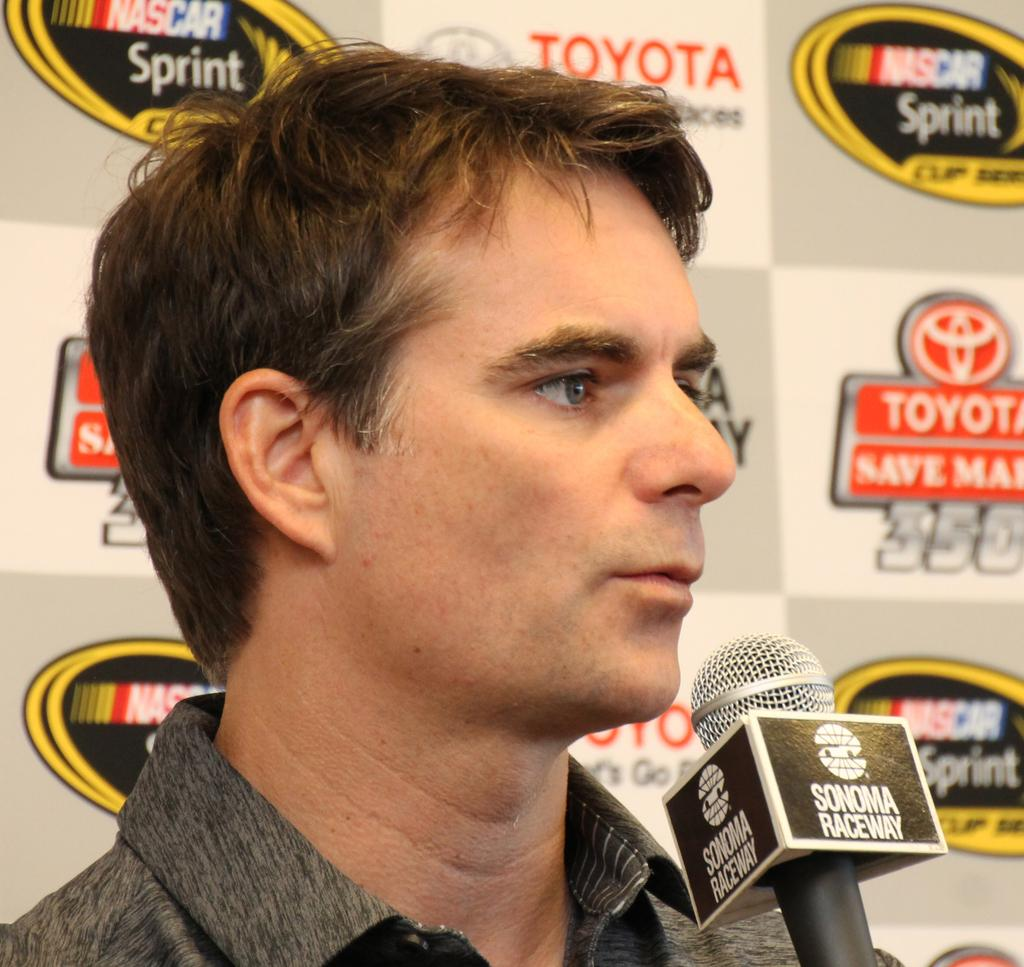Who is present in the image? There is a man in the image. What is the man doing in the image? The man is speaking in the image. What tool is the man using while speaking? The man is using a microphone in the image. What else can be seen in the image besides the man? There is an advertisement board visible in the image. How many legs does the man have in the image? The number of legs cannot be determined from the image, as only the man's upper body is visible. 